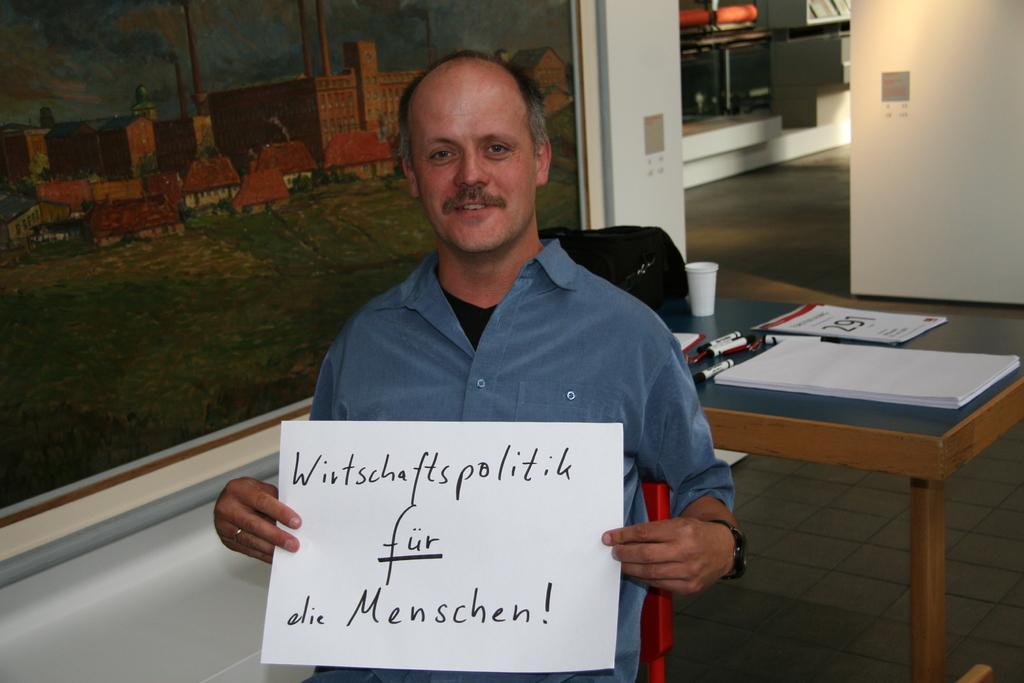Can you describe this image briefly? In this picture a man is seated on the chair, he is holding a paper in his hands, in the background we can see a wall painting and couple of papers, pens, cups on the table. 